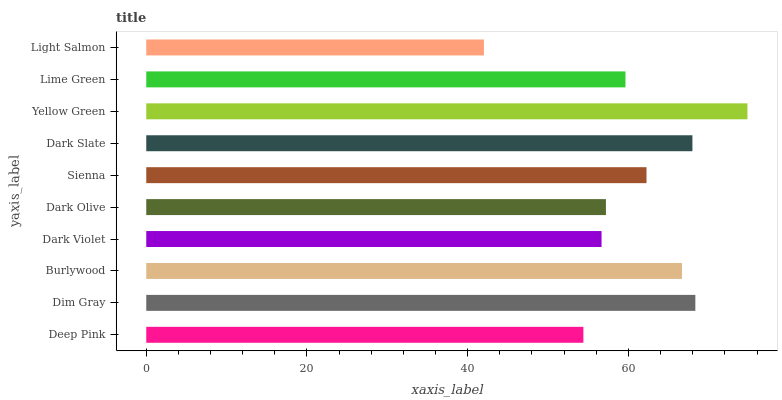Is Light Salmon the minimum?
Answer yes or no. Yes. Is Yellow Green the maximum?
Answer yes or no. Yes. Is Dim Gray the minimum?
Answer yes or no. No. Is Dim Gray the maximum?
Answer yes or no. No. Is Dim Gray greater than Deep Pink?
Answer yes or no. Yes. Is Deep Pink less than Dim Gray?
Answer yes or no. Yes. Is Deep Pink greater than Dim Gray?
Answer yes or no. No. Is Dim Gray less than Deep Pink?
Answer yes or no. No. Is Sienna the high median?
Answer yes or no. Yes. Is Lime Green the low median?
Answer yes or no. Yes. Is Dark Olive the high median?
Answer yes or no. No. Is Sienna the low median?
Answer yes or no. No. 